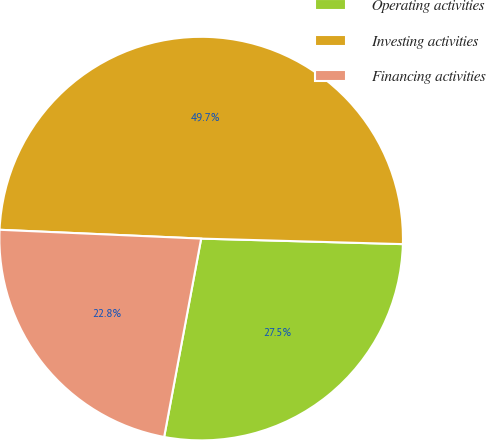Convert chart. <chart><loc_0><loc_0><loc_500><loc_500><pie_chart><fcel>Operating activities<fcel>Investing activities<fcel>Financing activities<nl><fcel>27.5%<fcel>49.74%<fcel>22.76%<nl></chart> 